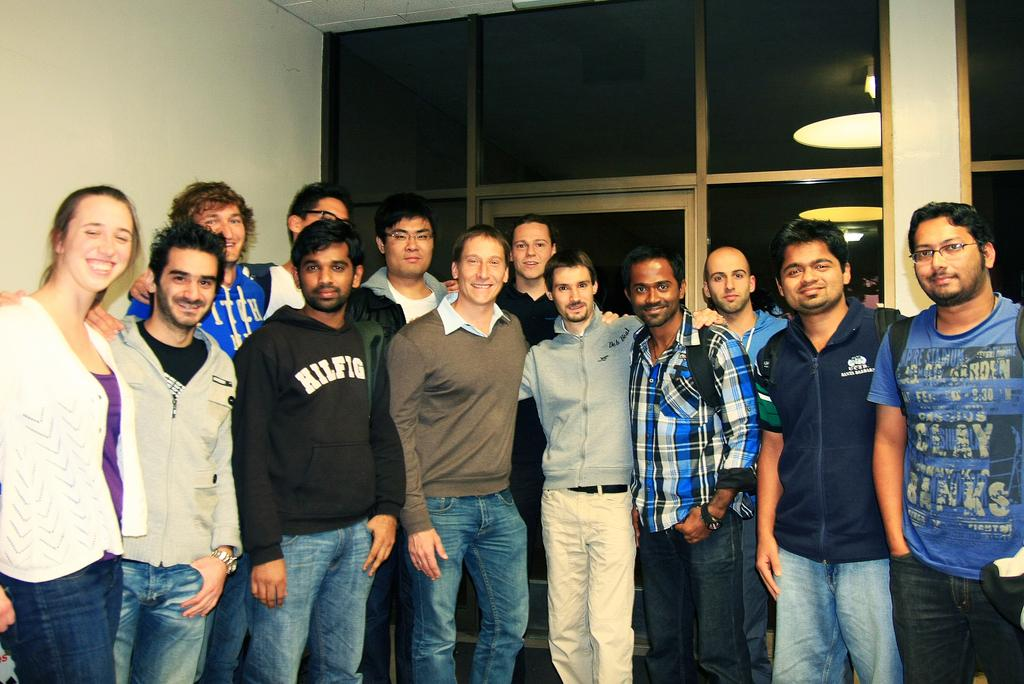What can be observed about the people in the image? There are people standing in the image, including men and a woman. How are the people in the image feeling? The people in the image are smiling. What is located on the left side of the image? There is a wall on the left side of the image. What architectural feature can be seen in the background of the image? There is a glass door in the background of the image. What type of body is visible in the image? There is no body present in the image; it features people standing and smiling. What kind of voyage are the people embarking on in the image? There is no indication of a voyage in the image; the people are simply standing and smiling. 